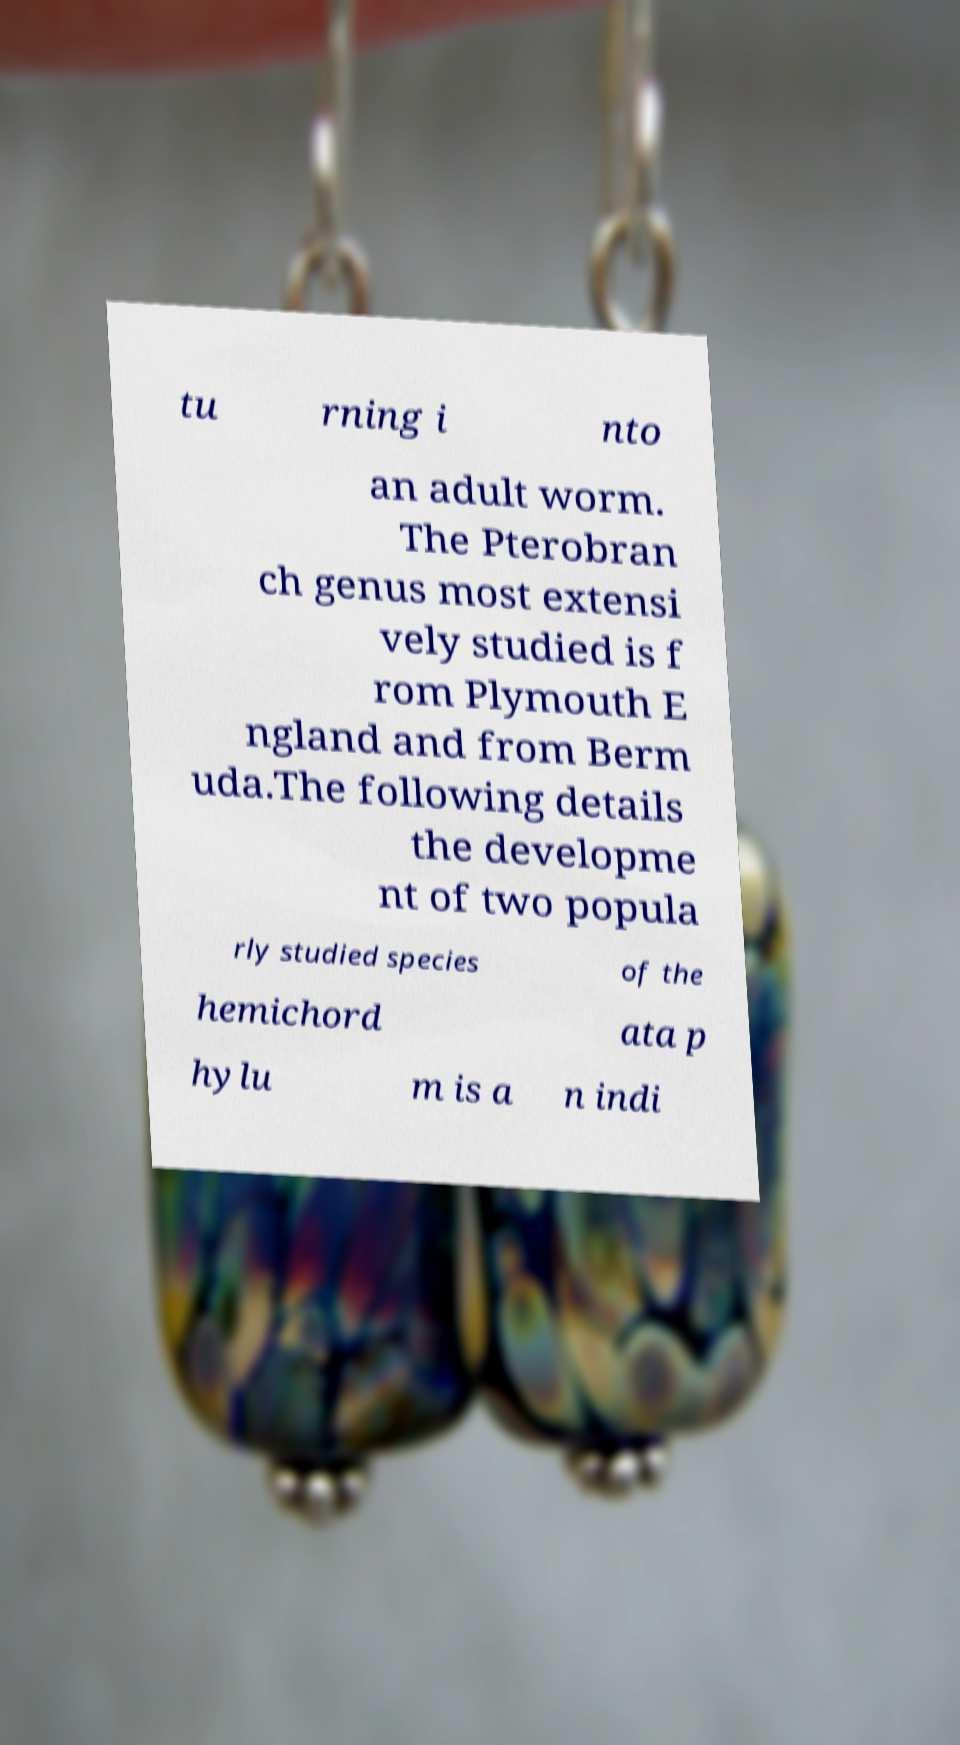Please read and relay the text visible in this image. What does it say? tu rning i nto an adult worm. The Pterobran ch genus most extensi vely studied is f rom Plymouth E ngland and from Berm uda.The following details the developme nt of two popula rly studied species of the hemichord ata p hylu m is a n indi 